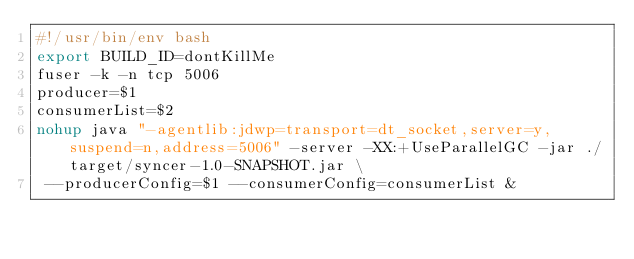Convert code to text. <code><loc_0><loc_0><loc_500><loc_500><_Bash_>#!/usr/bin/env bash
export BUILD_ID=dontKillMe
fuser -k -n tcp 5006
producer=$1
consumerList=$2
nohup java "-agentlib:jdwp=transport=dt_socket,server=y,suspend=n,address=5006" -server -XX:+UseParallelGC -jar ./target/syncer-1.0-SNAPSHOT.jar \
 --producerConfig=$1 --consumerConfig=consumerList &
</code> 